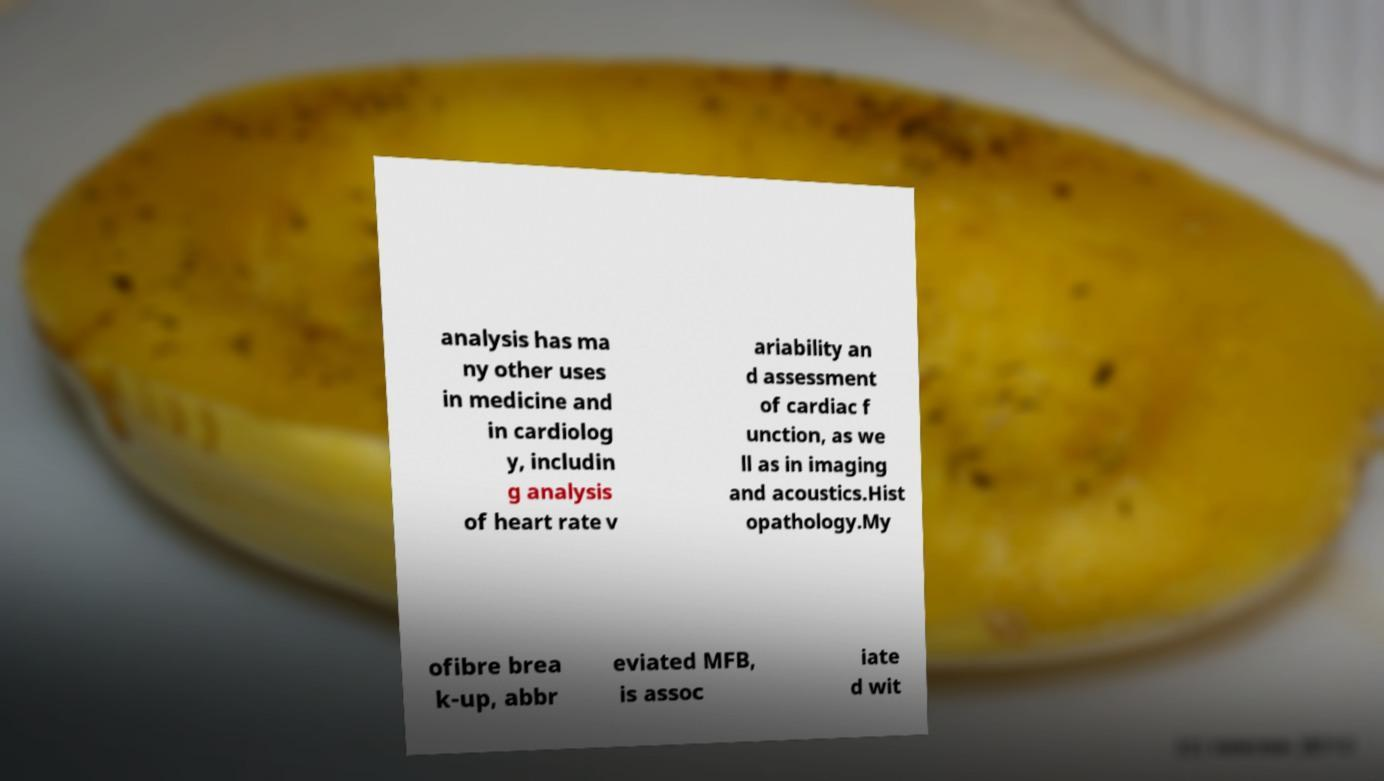There's text embedded in this image that I need extracted. Can you transcribe it verbatim? analysis has ma ny other uses in medicine and in cardiolog y, includin g analysis of heart rate v ariability an d assessment of cardiac f unction, as we ll as in imaging and acoustics.Hist opathology.My ofibre brea k-up, abbr eviated MFB, is assoc iate d wit 